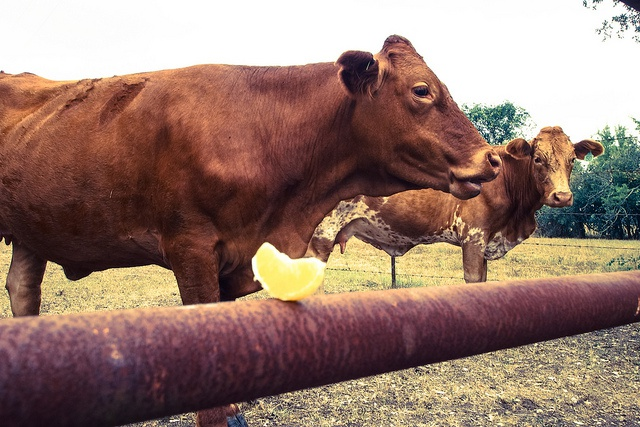Describe the objects in this image and their specific colors. I can see cow in white, maroon, black, and brown tones, cow in white, maroon, brown, black, and tan tones, and orange in white, khaki, beige, and gray tones in this image. 